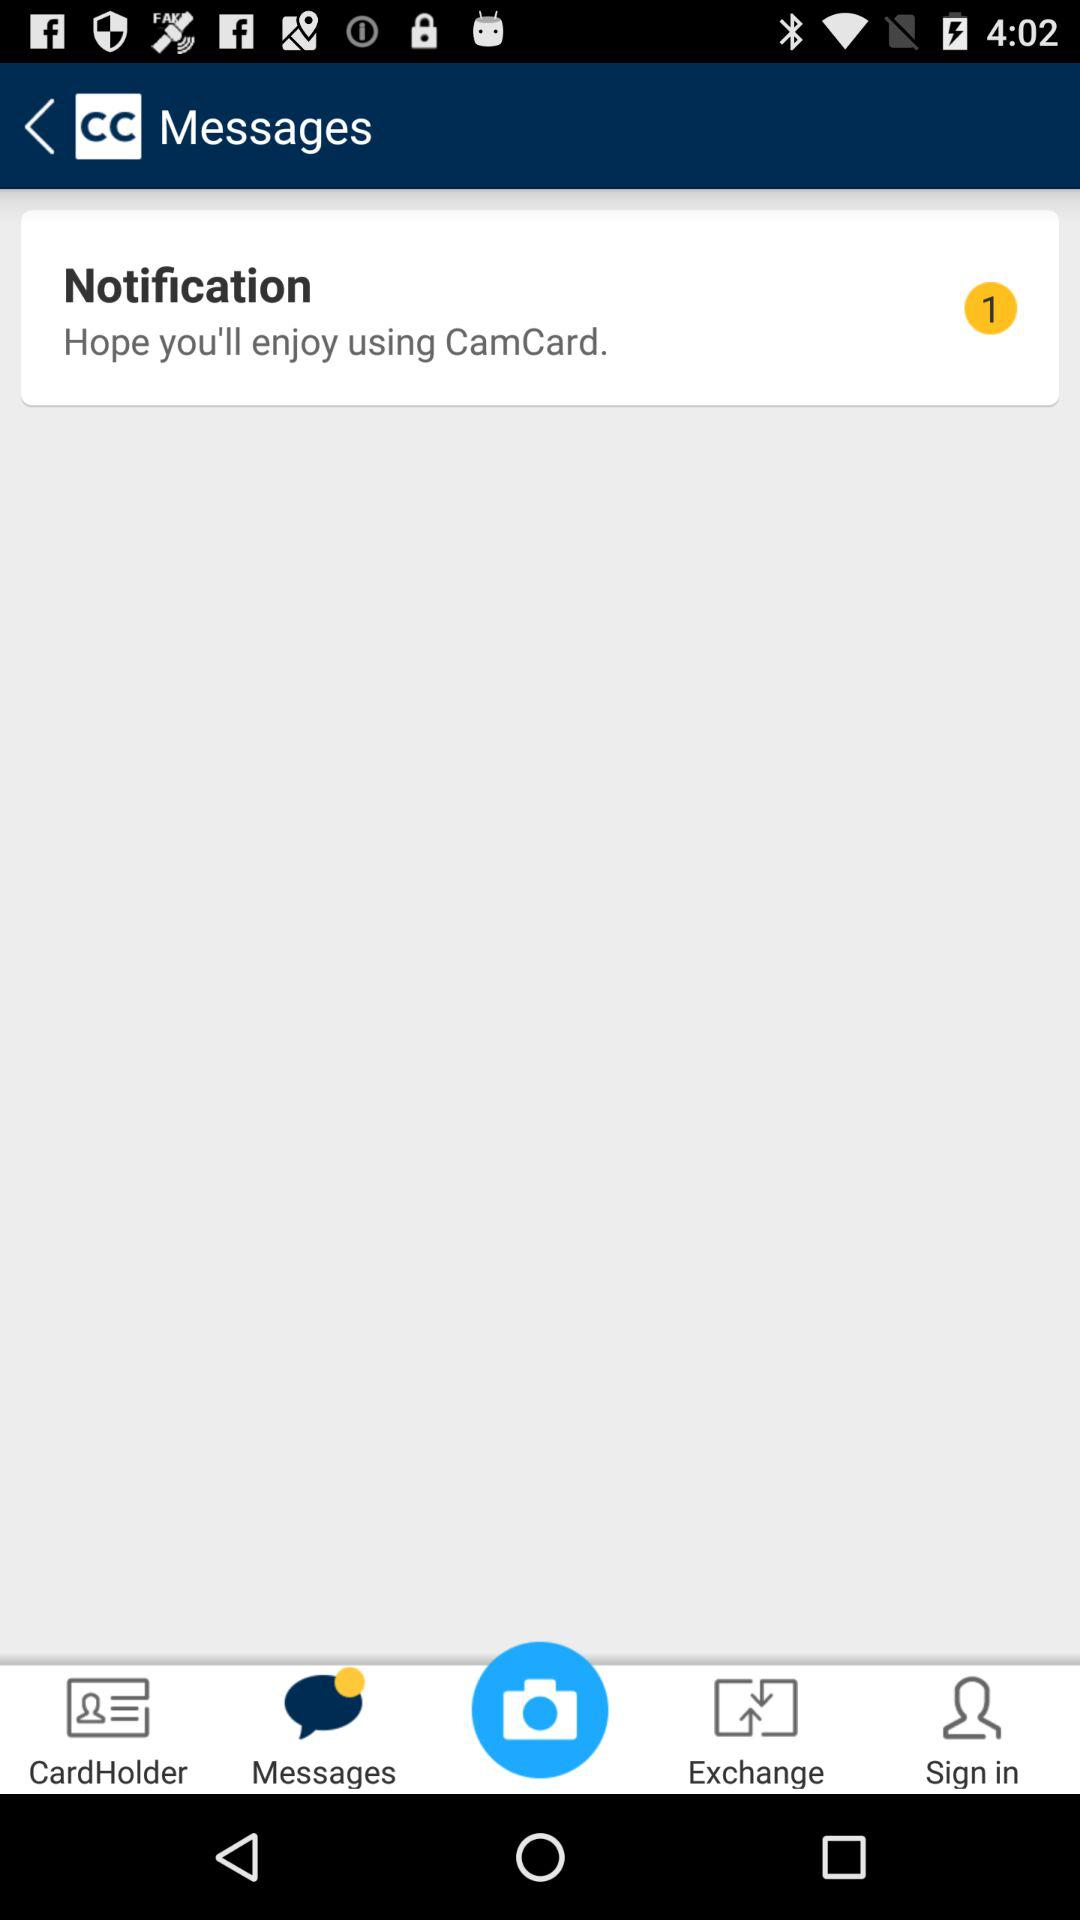How many notifications are unread? There is only one unread notification. 